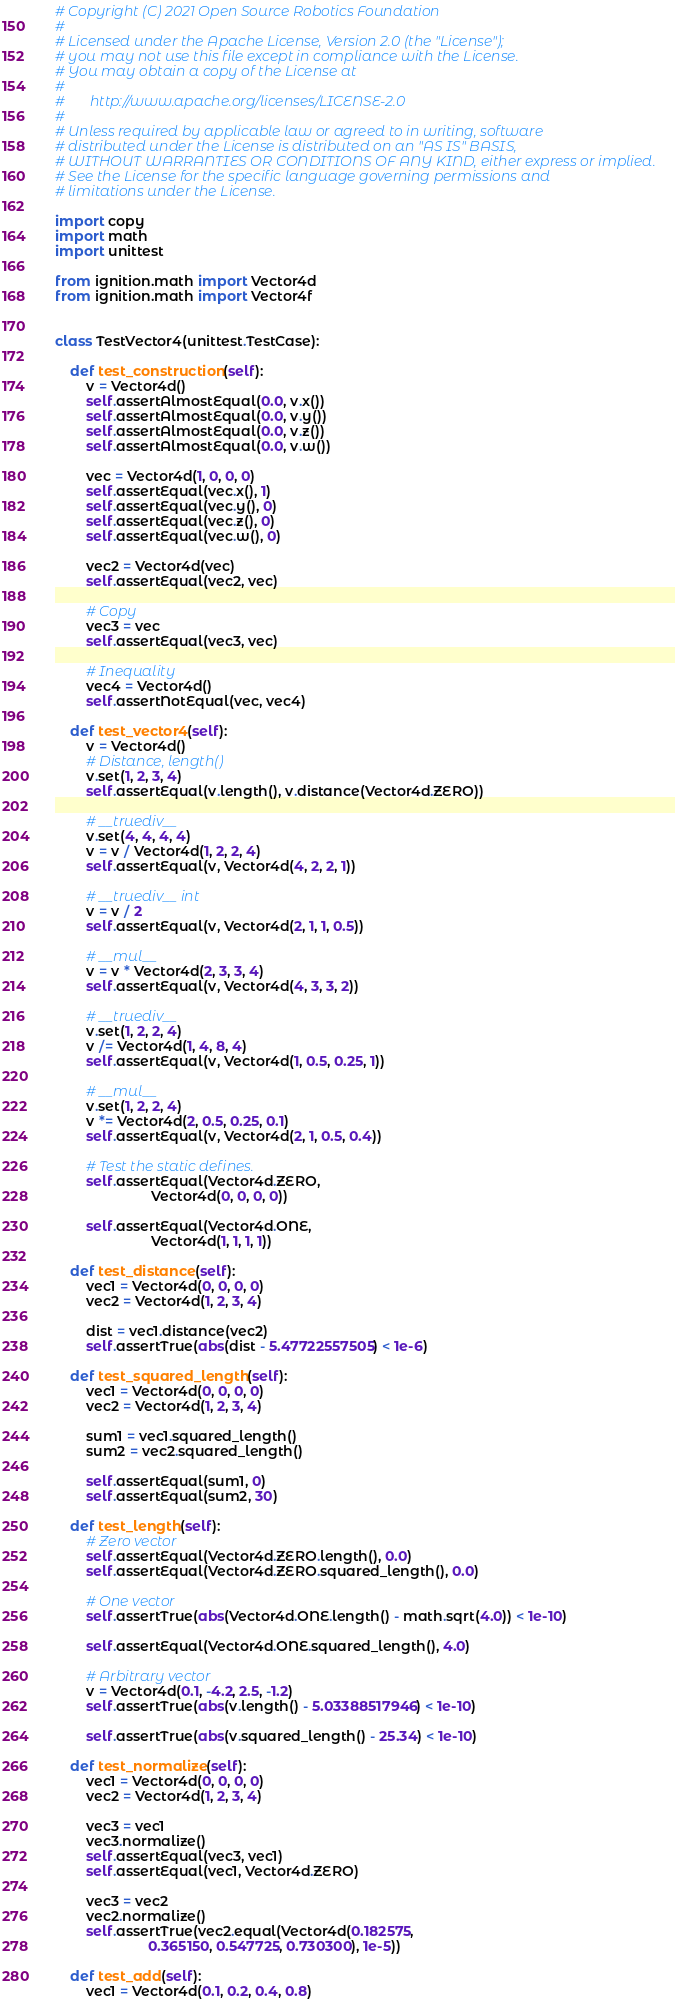<code> <loc_0><loc_0><loc_500><loc_500><_Python_># Copyright (C) 2021 Open Source Robotics Foundation
#
# Licensed under the Apache License, Version 2.0 (the "License");
# you may not use this file except in compliance with the License.
# You may obtain a copy of the License at
#
#       http://www.apache.org/licenses/LICENSE-2.0
#
# Unless required by applicable law or agreed to in writing, software
# distributed under the License is distributed on an "AS IS" BASIS,
# WITHOUT WARRANTIES OR CONDITIONS OF ANY KIND, either express or implied.
# See the License for the specific language governing permissions and
# limitations under the License.

import copy
import math
import unittest

from ignition.math import Vector4d
from ignition.math import Vector4f


class TestVector4(unittest.TestCase):

    def test_construction(self):
        v = Vector4d()
        self.assertAlmostEqual(0.0, v.x())
        self.assertAlmostEqual(0.0, v.y())
        self.assertAlmostEqual(0.0, v.z())
        self.assertAlmostEqual(0.0, v.w())

        vec = Vector4d(1, 0, 0, 0)
        self.assertEqual(vec.x(), 1)
        self.assertEqual(vec.y(), 0)
        self.assertEqual(vec.z(), 0)
        self.assertEqual(vec.w(), 0)

        vec2 = Vector4d(vec)
        self.assertEqual(vec2, vec)

        # Copy
        vec3 = vec
        self.assertEqual(vec3, vec)

        # Inequality
        vec4 = Vector4d()
        self.assertNotEqual(vec, vec4)

    def test_vector4(self):
        v = Vector4d()
        # Distance, length()
        v.set(1, 2, 3, 4)
        self.assertEqual(v.length(), v.distance(Vector4d.ZERO))

        # __truediv__
        v.set(4, 4, 4, 4)
        v = v / Vector4d(1, 2, 2, 4)
        self.assertEqual(v, Vector4d(4, 2, 2, 1))

        # __truediv__ int
        v = v / 2
        self.assertEqual(v, Vector4d(2, 1, 1, 0.5))

        # __mul__
        v = v * Vector4d(2, 3, 3, 4)
        self.assertEqual(v, Vector4d(4, 3, 3, 2))

        # __truediv__
        v.set(1, 2, 2, 4)
        v /= Vector4d(1, 4, 8, 4)
        self.assertEqual(v, Vector4d(1, 0.5, 0.25, 1))

        # __mul__
        v.set(1, 2, 2, 4)
        v *= Vector4d(2, 0.5, 0.25, 0.1)
        self.assertEqual(v, Vector4d(2, 1, 0.5, 0.4))

        # Test the static defines.
        self.assertEqual(Vector4d.ZERO,
                         Vector4d(0, 0, 0, 0))

        self.assertEqual(Vector4d.ONE,
                         Vector4d(1, 1, 1, 1))

    def test_distance(self):
        vec1 = Vector4d(0, 0, 0, 0)
        vec2 = Vector4d(1, 2, 3, 4)

        dist = vec1.distance(vec2)
        self.assertTrue(abs(dist - 5.47722557505) < 1e-6)

    def test_squared_length(self):
        vec1 = Vector4d(0, 0, 0, 0)
        vec2 = Vector4d(1, 2, 3, 4)

        sum1 = vec1.squared_length()
        sum2 = vec2.squared_length()

        self.assertEqual(sum1, 0)
        self.assertEqual(sum2, 30)

    def test_length(self):
        # Zero vector
        self.assertEqual(Vector4d.ZERO.length(), 0.0)
        self.assertEqual(Vector4d.ZERO.squared_length(), 0.0)

        # One vector
        self.assertTrue(abs(Vector4d.ONE.length() - math.sqrt(4.0)) < 1e-10)

        self.assertEqual(Vector4d.ONE.squared_length(), 4.0)

        # Arbitrary vector
        v = Vector4d(0.1, -4.2, 2.5, -1.2)
        self.assertTrue(abs(v.length() - 5.03388517946) < 1e-10)

        self.assertTrue(abs(v.squared_length() - 25.34) < 1e-10)

    def test_normalize(self):
        vec1 = Vector4d(0, 0, 0, 0)
        vec2 = Vector4d(1, 2, 3, 4)

        vec3 = vec1
        vec3.normalize()
        self.assertEqual(vec3, vec1)
        self.assertEqual(vec1, Vector4d.ZERO)

        vec3 = vec2
        vec2.normalize()
        self.assertTrue(vec2.equal(Vector4d(0.182575,
                        0.365150, 0.547725, 0.730300), 1e-5))

    def test_add(self):
        vec1 = Vector4d(0.1, 0.2, 0.4, 0.8)</code> 